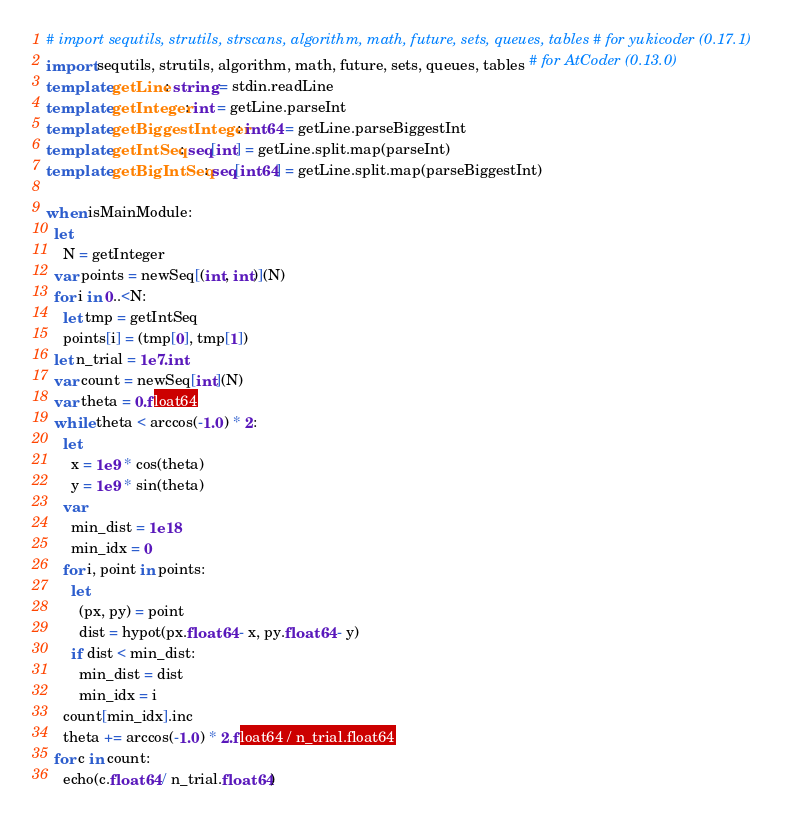Convert code to text. <code><loc_0><loc_0><loc_500><loc_500><_Nim_># import sequtils, strutils, strscans, algorithm, math, future, sets, queues, tables # for yukicoder (0.17.1)
import sequtils, strutils, algorithm, math, future, sets, queues, tables # for AtCoder (0.13.0)
template getLine: string = stdin.readLine
template getInteger: int = getLine.parseInt
template getBiggestInteger: int64 = getLine.parseBiggestInt
template getIntSeq: seq[int] = getLine.split.map(parseInt)
template getBigIntSeq: seq[int64] = getLine.split.map(parseBiggestInt)

when isMainModule:
  let
    N = getInteger
  var points = newSeq[(int, int)](N)
  for i in 0..<N:
    let tmp = getIntSeq
    points[i] = (tmp[0], tmp[1])
  let n_trial = 1e7.int
  var count = newSeq[int](N)
  var theta = 0.float64
  while theta < arccos(-1.0) * 2:
    let
      x = 1e9 * cos(theta)
      y = 1e9 * sin(theta)
    var
      min_dist = 1e18
      min_idx = 0
    for i, point in points:
      let
        (px, py) = point
        dist = hypot(px.float64 - x, py.float64 - y)
      if dist < min_dist:
        min_dist = dist
        min_idx = i
    count[min_idx].inc
    theta += arccos(-1.0) * 2.float64 / n_trial.float64
  for c in count:
    echo(c.float64 / n_trial.float64)
</code> 